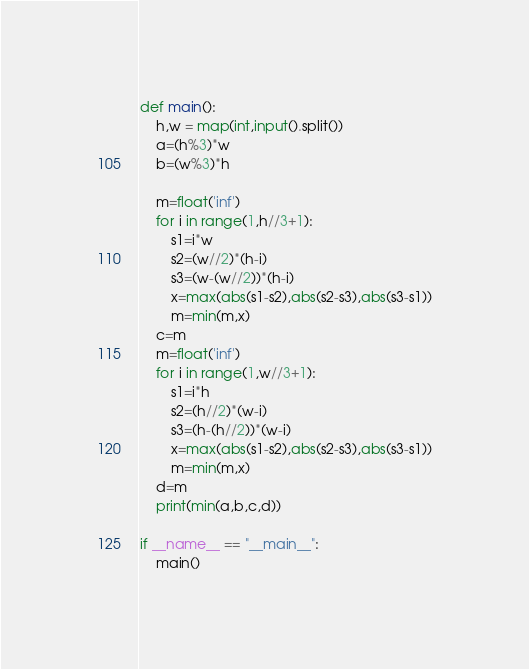<code> <loc_0><loc_0><loc_500><loc_500><_Python_>def main():
    h,w = map(int,input().split())
    a=(h%3)*w
    b=(w%3)*h

    m=float('inf')
    for i in range(1,h//3+1):
        s1=i*w
        s2=(w//2)*(h-i)
        s3=(w-(w//2))*(h-i)
        x=max(abs(s1-s2),abs(s2-s3),abs(s3-s1))
        m=min(m,x)
    c=m
    m=float('inf')
    for i in range(1,w//3+1):
        s1=i*h
        s2=(h//2)*(w-i)
        s3=(h-(h//2))*(w-i)
        x=max(abs(s1-s2),abs(s2-s3),abs(s3-s1))
        m=min(m,x)
    d=m
    print(min(a,b,c,d))
    
if __name__ == "__main__":
    main()
</code> 